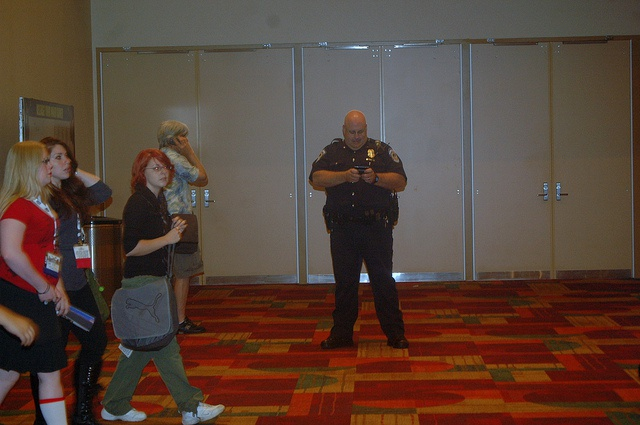Describe the objects in this image and their specific colors. I can see people in maroon, black, and gray tones, people in maroon, black, and gray tones, people in maroon, black, and gray tones, people in maroon, black, and gray tones, and people in maroon, black, and gray tones in this image. 